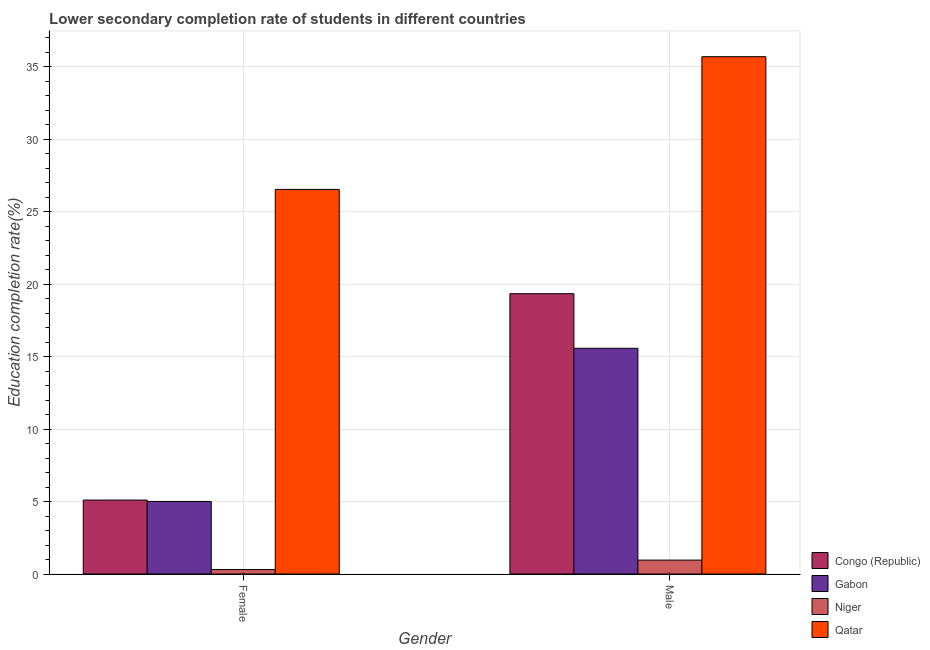Are the number of bars per tick equal to the number of legend labels?
Offer a very short reply. Yes. Are the number of bars on each tick of the X-axis equal?
Your response must be concise. Yes. How many bars are there on the 1st tick from the left?
Your answer should be compact. 4. How many bars are there on the 2nd tick from the right?
Offer a terse response. 4. What is the label of the 1st group of bars from the left?
Offer a terse response. Female. What is the education completion rate of female students in Qatar?
Offer a terse response. 26.53. Across all countries, what is the maximum education completion rate of female students?
Offer a very short reply. 26.53. Across all countries, what is the minimum education completion rate of female students?
Your answer should be compact. 0.31. In which country was the education completion rate of female students maximum?
Give a very brief answer. Qatar. In which country was the education completion rate of male students minimum?
Offer a terse response. Niger. What is the total education completion rate of female students in the graph?
Give a very brief answer. 36.94. What is the difference between the education completion rate of female students in Gabon and that in Niger?
Make the answer very short. 4.7. What is the difference between the education completion rate of male students in Niger and the education completion rate of female students in Gabon?
Make the answer very short. -4.05. What is the average education completion rate of male students per country?
Keep it short and to the point. 17.89. What is the difference between the education completion rate of male students and education completion rate of female students in Congo (Republic)?
Your answer should be compact. 14.24. What is the ratio of the education completion rate of female students in Niger to that in Qatar?
Make the answer very short. 0.01. Is the education completion rate of female students in Gabon less than that in Niger?
Your answer should be very brief. No. What does the 1st bar from the left in Female represents?
Your answer should be compact. Congo (Republic). What does the 2nd bar from the right in Female represents?
Your response must be concise. Niger. How many bars are there?
Your answer should be very brief. 8. Are all the bars in the graph horizontal?
Offer a very short reply. No. What is the difference between two consecutive major ticks on the Y-axis?
Make the answer very short. 5. Are the values on the major ticks of Y-axis written in scientific E-notation?
Ensure brevity in your answer.  No. Does the graph contain any zero values?
Provide a succinct answer. No. Where does the legend appear in the graph?
Your answer should be very brief. Bottom right. How many legend labels are there?
Ensure brevity in your answer.  4. How are the legend labels stacked?
Your answer should be very brief. Vertical. What is the title of the graph?
Provide a short and direct response. Lower secondary completion rate of students in different countries. What is the label or title of the Y-axis?
Keep it short and to the point. Education completion rate(%). What is the Education completion rate(%) of Congo (Republic) in Female?
Your answer should be very brief. 5.1. What is the Education completion rate(%) of Gabon in Female?
Give a very brief answer. 5.01. What is the Education completion rate(%) of Niger in Female?
Ensure brevity in your answer.  0.31. What is the Education completion rate(%) in Qatar in Female?
Make the answer very short. 26.53. What is the Education completion rate(%) in Congo (Republic) in Male?
Keep it short and to the point. 19.33. What is the Education completion rate(%) of Gabon in Male?
Offer a very short reply. 15.57. What is the Education completion rate(%) of Niger in Male?
Provide a short and direct response. 0.96. What is the Education completion rate(%) in Qatar in Male?
Offer a very short reply. 35.68. Across all Gender, what is the maximum Education completion rate(%) of Congo (Republic)?
Give a very brief answer. 19.33. Across all Gender, what is the maximum Education completion rate(%) in Gabon?
Offer a terse response. 15.57. Across all Gender, what is the maximum Education completion rate(%) of Niger?
Ensure brevity in your answer.  0.96. Across all Gender, what is the maximum Education completion rate(%) in Qatar?
Your response must be concise. 35.68. Across all Gender, what is the minimum Education completion rate(%) of Congo (Republic)?
Ensure brevity in your answer.  5.1. Across all Gender, what is the minimum Education completion rate(%) of Gabon?
Your answer should be compact. 5.01. Across all Gender, what is the minimum Education completion rate(%) of Niger?
Give a very brief answer. 0.31. Across all Gender, what is the minimum Education completion rate(%) in Qatar?
Your answer should be very brief. 26.53. What is the total Education completion rate(%) in Congo (Republic) in the graph?
Provide a succinct answer. 24.43. What is the total Education completion rate(%) of Gabon in the graph?
Give a very brief answer. 20.57. What is the total Education completion rate(%) of Niger in the graph?
Your response must be concise. 1.27. What is the total Education completion rate(%) in Qatar in the graph?
Ensure brevity in your answer.  62.21. What is the difference between the Education completion rate(%) in Congo (Republic) in Female and that in Male?
Your answer should be very brief. -14.23. What is the difference between the Education completion rate(%) in Gabon in Female and that in Male?
Make the answer very short. -10.56. What is the difference between the Education completion rate(%) of Niger in Female and that in Male?
Your answer should be very brief. -0.65. What is the difference between the Education completion rate(%) of Qatar in Female and that in Male?
Your response must be concise. -9.15. What is the difference between the Education completion rate(%) of Congo (Republic) in Female and the Education completion rate(%) of Gabon in Male?
Provide a succinct answer. -10.47. What is the difference between the Education completion rate(%) in Congo (Republic) in Female and the Education completion rate(%) in Niger in Male?
Your answer should be very brief. 4.14. What is the difference between the Education completion rate(%) in Congo (Republic) in Female and the Education completion rate(%) in Qatar in Male?
Your response must be concise. -30.58. What is the difference between the Education completion rate(%) of Gabon in Female and the Education completion rate(%) of Niger in Male?
Provide a succinct answer. 4.05. What is the difference between the Education completion rate(%) of Gabon in Female and the Education completion rate(%) of Qatar in Male?
Your answer should be very brief. -30.68. What is the difference between the Education completion rate(%) of Niger in Female and the Education completion rate(%) of Qatar in Male?
Make the answer very short. -35.37. What is the average Education completion rate(%) of Congo (Republic) per Gender?
Provide a short and direct response. 12.22. What is the average Education completion rate(%) in Gabon per Gender?
Your response must be concise. 10.29. What is the average Education completion rate(%) in Niger per Gender?
Offer a very short reply. 0.63. What is the average Education completion rate(%) of Qatar per Gender?
Keep it short and to the point. 31.11. What is the difference between the Education completion rate(%) in Congo (Republic) and Education completion rate(%) in Gabon in Female?
Make the answer very short. 0.09. What is the difference between the Education completion rate(%) of Congo (Republic) and Education completion rate(%) of Niger in Female?
Your answer should be compact. 4.79. What is the difference between the Education completion rate(%) in Congo (Republic) and Education completion rate(%) in Qatar in Female?
Provide a short and direct response. -21.43. What is the difference between the Education completion rate(%) in Gabon and Education completion rate(%) in Niger in Female?
Your response must be concise. 4.7. What is the difference between the Education completion rate(%) of Gabon and Education completion rate(%) of Qatar in Female?
Your answer should be very brief. -21.52. What is the difference between the Education completion rate(%) of Niger and Education completion rate(%) of Qatar in Female?
Provide a succinct answer. -26.22. What is the difference between the Education completion rate(%) in Congo (Republic) and Education completion rate(%) in Gabon in Male?
Ensure brevity in your answer.  3.77. What is the difference between the Education completion rate(%) of Congo (Republic) and Education completion rate(%) of Niger in Male?
Provide a short and direct response. 18.38. What is the difference between the Education completion rate(%) of Congo (Republic) and Education completion rate(%) of Qatar in Male?
Your response must be concise. -16.35. What is the difference between the Education completion rate(%) of Gabon and Education completion rate(%) of Niger in Male?
Give a very brief answer. 14.61. What is the difference between the Education completion rate(%) of Gabon and Education completion rate(%) of Qatar in Male?
Offer a terse response. -20.11. What is the difference between the Education completion rate(%) in Niger and Education completion rate(%) in Qatar in Male?
Provide a short and direct response. -34.72. What is the ratio of the Education completion rate(%) in Congo (Republic) in Female to that in Male?
Keep it short and to the point. 0.26. What is the ratio of the Education completion rate(%) of Gabon in Female to that in Male?
Your response must be concise. 0.32. What is the ratio of the Education completion rate(%) of Niger in Female to that in Male?
Make the answer very short. 0.32. What is the ratio of the Education completion rate(%) of Qatar in Female to that in Male?
Offer a very short reply. 0.74. What is the difference between the highest and the second highest Education completion rate(%) in Congo (Republic)?
Keep it short and to the point. 14.24. What is the difference between the highest and the second highest Education completion rate(%) in Gabon?
Make the answer very short. 10.56. What is the difference between the highest and the second highest Education completion rate(%) of Niger?
Give a very brief answer. 0.65. What is the difference between the highest and the second highest Education completion rate(%) of Qatar?
Provide a short and direct response. 9.15. What is the difference between the highest and the lowest Education completion rate(%) of Congo (Republic)?
Your answer should be very brief. 14.23. What is the difference between the highest and the lowest Education completion rate(%) in Gabon?
Your answer should be very brief. 10.56. What is the difference between the highest and the lowest Education completion rate(%) in Niger?
Offer a terse response. 0.65. What is the difference between the highest and the lowest Education completion rate(%) of Qatar?
Give a very brief answer. 9.15. 